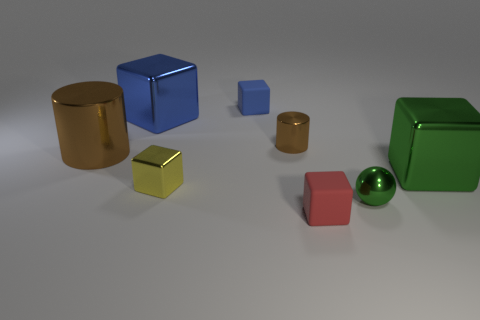There is a object that is the same color as the big metallic cylinder; what size is it?
Offer a very short reply. Small. What is the size of the yellow cube that is made of the same material as the ball?
Provide a succinct answer. Small. What is the shape of the small rubber object behind the shiny cube on the right side of the tiny cylinder?
Offer a terse response. Cube. How many brown things are tiny objects or tiny cubes?
Your answer should be compact. 1. Is there a big metallic cylinder in front of the small metallic thing that is right of the small block to the right of the tiny blue cube?
Your answer should be very brief. No. What is the shape of the object that is the same color as the large cylinder?
Offer a terse response. Cylinder. Is there anything else that has the same material as the green sphere?
Ensure brevity in your answer.  Yes. How many large objects are red rubber blocks or blue matte things?
Provide a short and direct response. 0. Does the tiny rubber thing that is behind the small sphere have the same shape as the big blue object?
Keep it short and to the point. Yes. Are there fewer tiny metallic blocks than large yellow spheres?
Your response must be concise. No. 